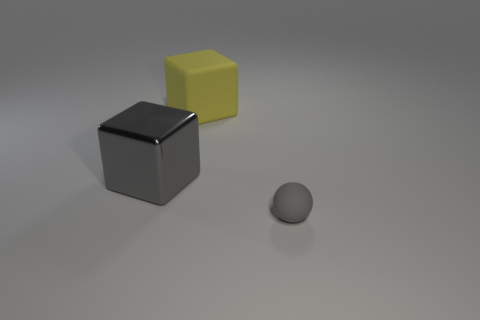Are there any other things that have the same shape as the tiny matte object?
Provide a succinct answer. No. Are there fewer large yellow matte blocks to the right of the big yellow matte cube than gray matte things?
Give a very brief answer. Yes. What is the shape of the yellow object that is the same material as the small gray thing?
Provide a succinct answer. Cube. Do the big yellow cube and the sphere have the same material?
Your answer should be very brief. Yes. Are there fewer yellow cubes that are behind the big yellow block than gray metal blocks in front of the gray matte thing?
Ensure brevity in your answer.  No. There is another thing that is the same color as the large metallic object; what size is it?
Make the answer very short. Small. There is a gray object on the left side of the matte object on the left side of the small gray rubber object; what number of cubes are to the right of it?
Ensure brevity in your answer.  1. Does the rubber ball have the same color as the large metal object?
Ensure brevity in your answer.  Yes. Is there a large shiny block that has the same color as the small matte ball?
Your response must be concise. Yes. What color is the block that is the same size as the shiny object?
Provide a succinct answer. Yellow. 